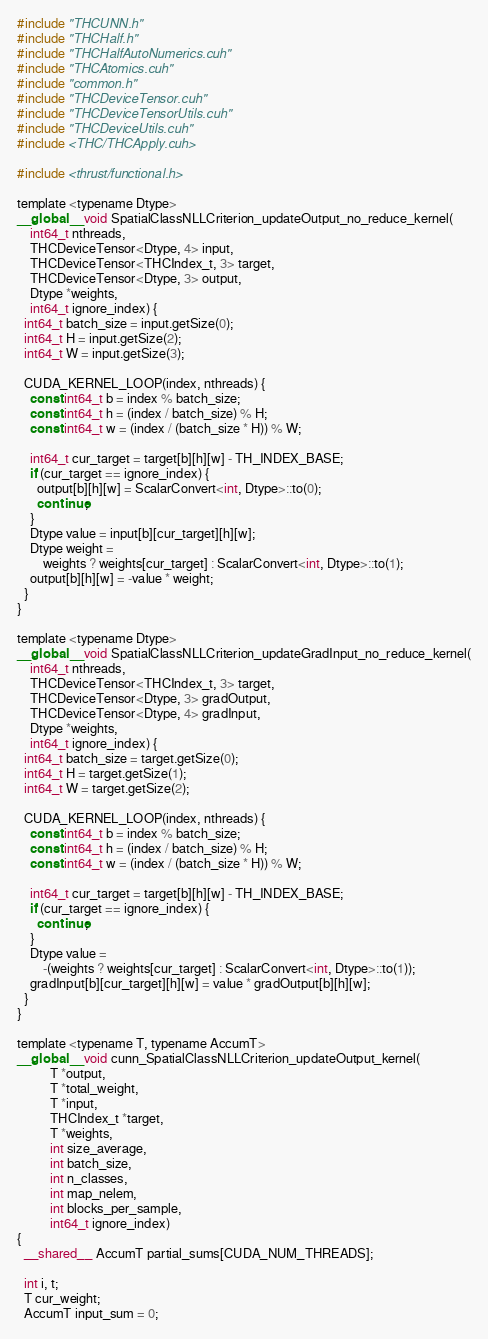<code> <loc_0><loc_0><loc_500><loc_500><_Cuda_>#include "THCUNN.h"
#include "THCHalf.h"
#include "THCHalfAutoNumerics.cuh"
#include "THCAtomics.cuh"
#include "common.h"
#include "THCDeviceTensor.cuh"
#include "THCDeviceTensorUtils.cuh"
#include "THCDeviceUtils.cuh"
#include <THC/THCApply.cuh>

#include <thrust/functional.h>

template <typename Dtype>
__global__ void SpatialClassNLLCriterion_updateOutput_no_reduce_kernel(
    int64_t nthreads,
    THCDeviceTensor<Dtype, 4> input,
    THCDeviceTensor<THCIndex_t, 3> target,
    THCDeviceTensor<Dtype, 3> output,
    Dtype *weights,
    int64_t ignore_index) {
  int64_t batch_size = input.getSize(0);
  int64_t H = input.getSize(2);
  int64_t W = input.getSize(3);

  CUDA_KERNEL_LOOP(index, nthreads) {
    const int64_t b = index % batch_size;
    const int64_t h = (index / batch_size) % H;
    const int64_t w = (index / (batch_size * H)) % W;

    int64_t cur_target = target[b][h][w] - TH_INDEX_BASE;
    if (cur_target == ignore_index) {
      output[b][h][w] = ScalarConvert<int, Dtype>::to(0);
      continue;
    }
    Dtype value = input[b][cur_target][h][w];
    Dtype weight =
        weights ? weights[cur_target] : ScalarConvert<int, Dtype>::to(1);
    output[b][h][w] = -value * weight;
  }
}

template <typename Dtype>
__global__ void SpatialClassNLLCriterion_updateGradInput_no_reduce_kernel(
    int64_t nthreads,
    THCDeviceTensor<THCIndex_t, 3> target,
    THCDeviceTensor<Dtype, 3> gradOutput,
    THCDeviceTensor<Dtype, 4> gradInput,
    Dtype *weights,
    int64_t ignore_index) {
  int64_t batch_size = target.getSize(0);
  int64_t H = target.getSize(1);
  int64_t W = target.getSize(2);

  CUDA_KERNEL_LOOP(index, nthreads) {
    const int64_t b = index % batch_size;
    const int64_t h = (index / batch_size) % H;
    const int64_t w = (index / (batch_size * H)) % W;

    int64_t cur_target = target[b][h][w] - TH_INDEX_BASE;
    if (cur_target == ignore_index) {
      continue;
    }
    Dtype value =
        -(weights ? weights[cur_target] : ScalarConvert<int, Dtype>::to(1));
    gradInput[b][cur_target][h][w] = value * gradOutput[b][h][w];
  }
}

template <typename T, typename AccumT>
__global__ void cunn_SpatialClassNLLCriterion_updateOutput_kernel(
          T *output,
          T *total_weight,
          T *input,
          THCIndex_t *target,
          T *weights,
          int size_average,
          int batch_size,
          int n_classes,
          int map_nelem,
          int blocks_per_sample,
          int64_t ignore_index)
{
  __shared__ AccumT partial_sums[CUDA_NUM_THREADS];

  int i, t;
  T cur_weight;
  AccumT input_sum = 0;</code> 